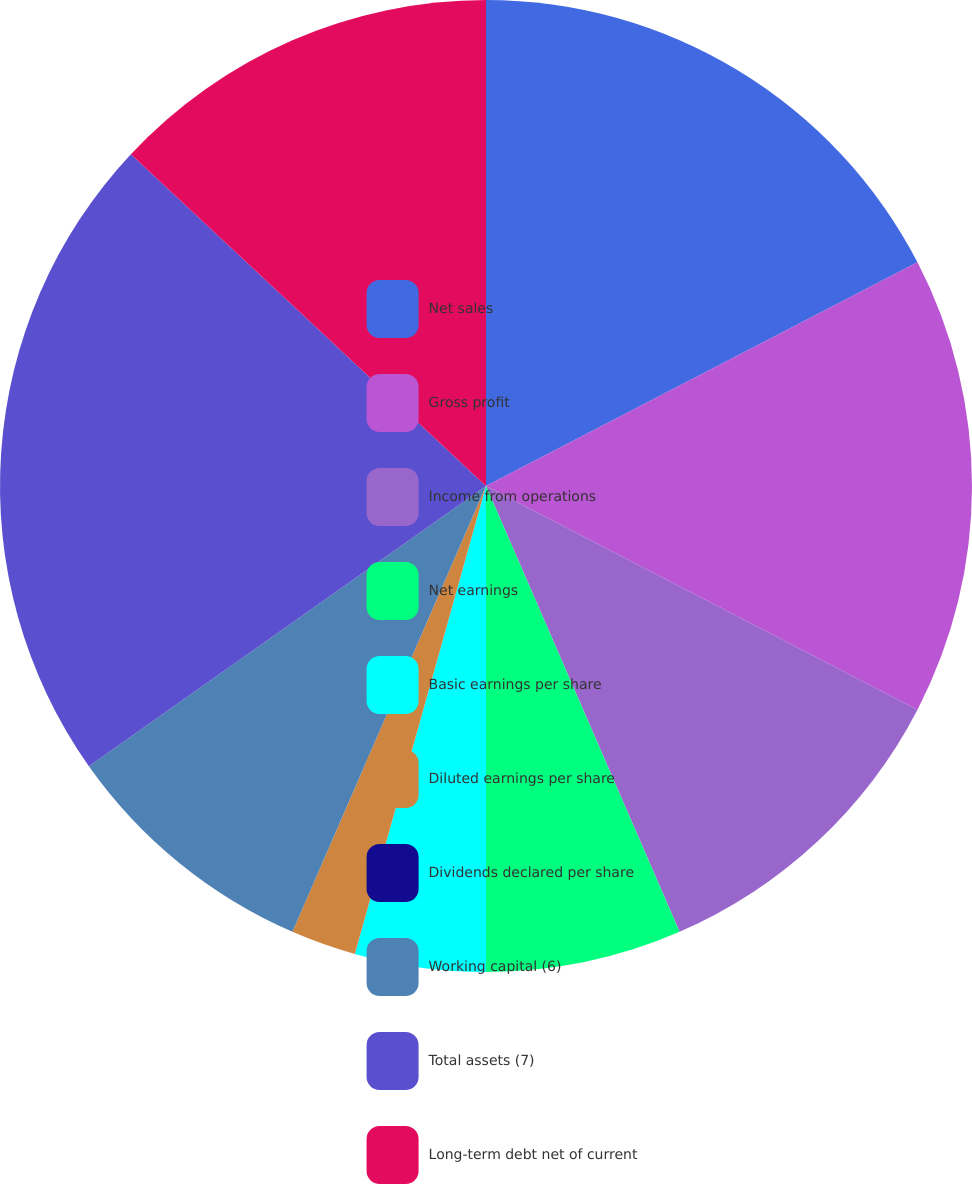Convert chart to OTSL. <chart><loc_0><loc_0><loc_500><loc_500><pie_chart><fcel>Net sales<fcel>Gross profit<fcel>Income from operations<fcel>Net earnings<fcel>Basic earnings per share<fcel>Diluted earnings per share<fcel>Dividends declared per share<fcel>Working capital (6)<fcel>Total assets (7)<fcel>Long-term debt net of current<nl><fcel>17.39%<fcel>15.22%<fcel>10.87%<fcel>6.52%<fcel>4.35%<fcel>2.17%<fcel>0.0%<fcel>8.7%<fcel>21.74%<fcel>13.04%<nl></chart> 